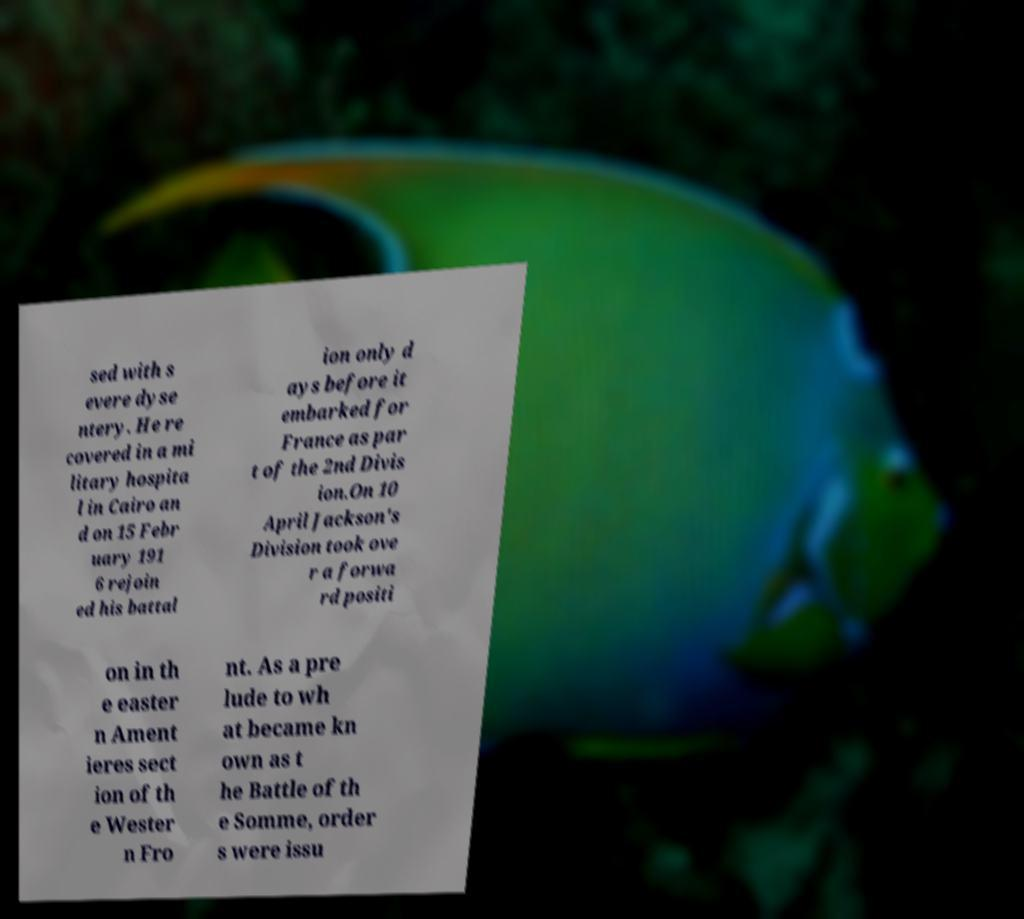Could you extract and type out the text from this image? sed with s evere dyse ntery. He re covered in a mi litary hospita l in Cairo an d on 15 Febr uary 191 6 rejoin ed his battal ion only d ays before it embarked for France as par t of the 2nd Divis ion.On 10 April Jackson's Division took ove r a forwa rd positi on in th e easter n Ament ieres sect ion of th e Wester n Fro nt. As a pre lude to wh at became kn own as t he Battle of th e Somme, order s were issu 